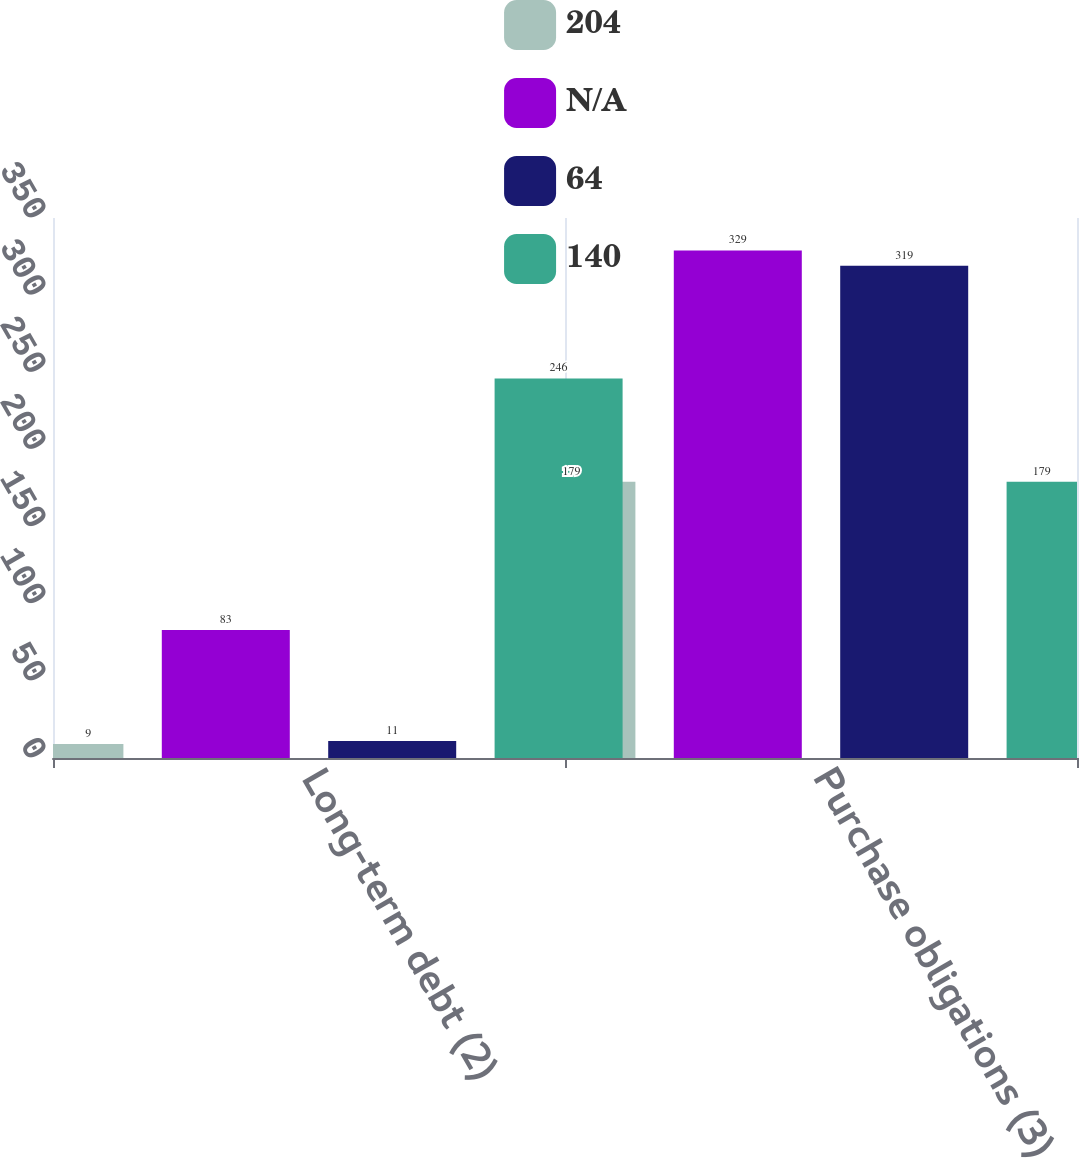<chart> <loc_0><loc_0><loc_500><loc_500><stacked_bar_chart><ecel><fcel>Long-term debt (2)<fcel>Purchase obligations (3)<nl><fcel>204<fcel>9<fcel>179<nl><fcel>nan<fcel>83<fcel>329<nl><fcel>64<fcel>11<fcel>319<nl><fcel>140<fcel>246<fcel>179<nl></chart> 